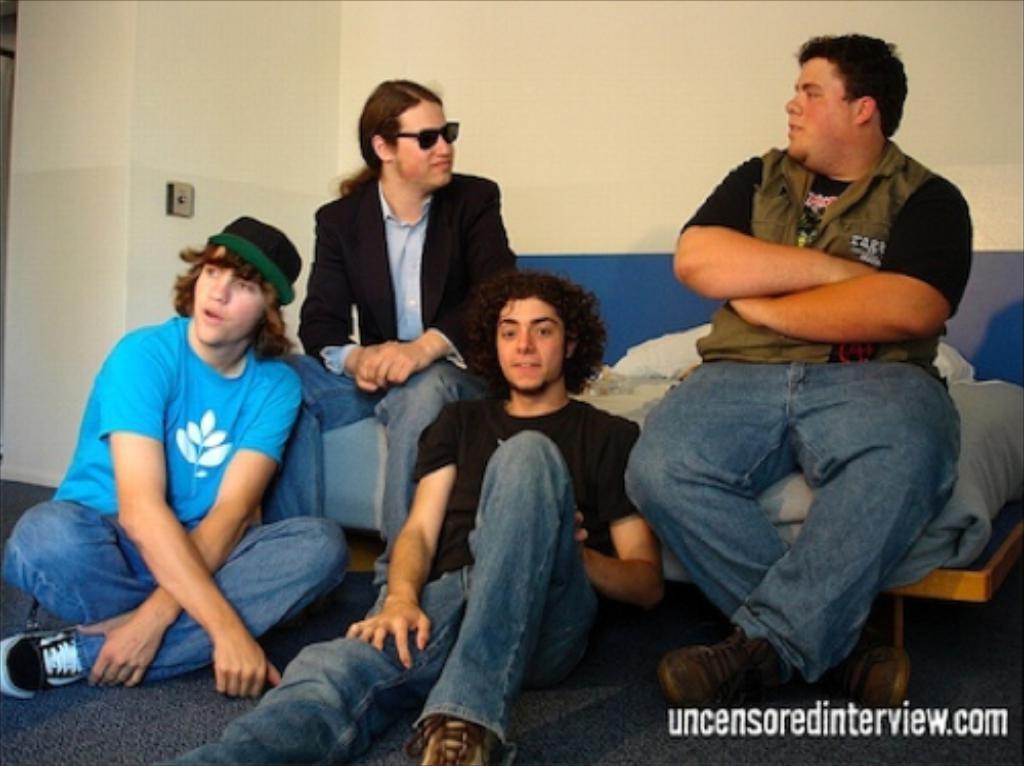Could you give a brief overview of what you see in this image? In this image I can see five men are sitting. I can see one of them is wearing a cap and one is wearing black shades. Behind them I can see a table, few clothes and a blue colour thing. I can also see a watermark on the bottom right side of this image. 